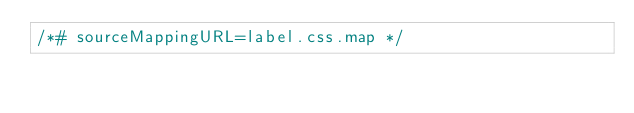<code> <loc_0><loc_0><loc_500><loc_500><_CSS_>/*# sourceMappingURL=label.css.map */</code> 